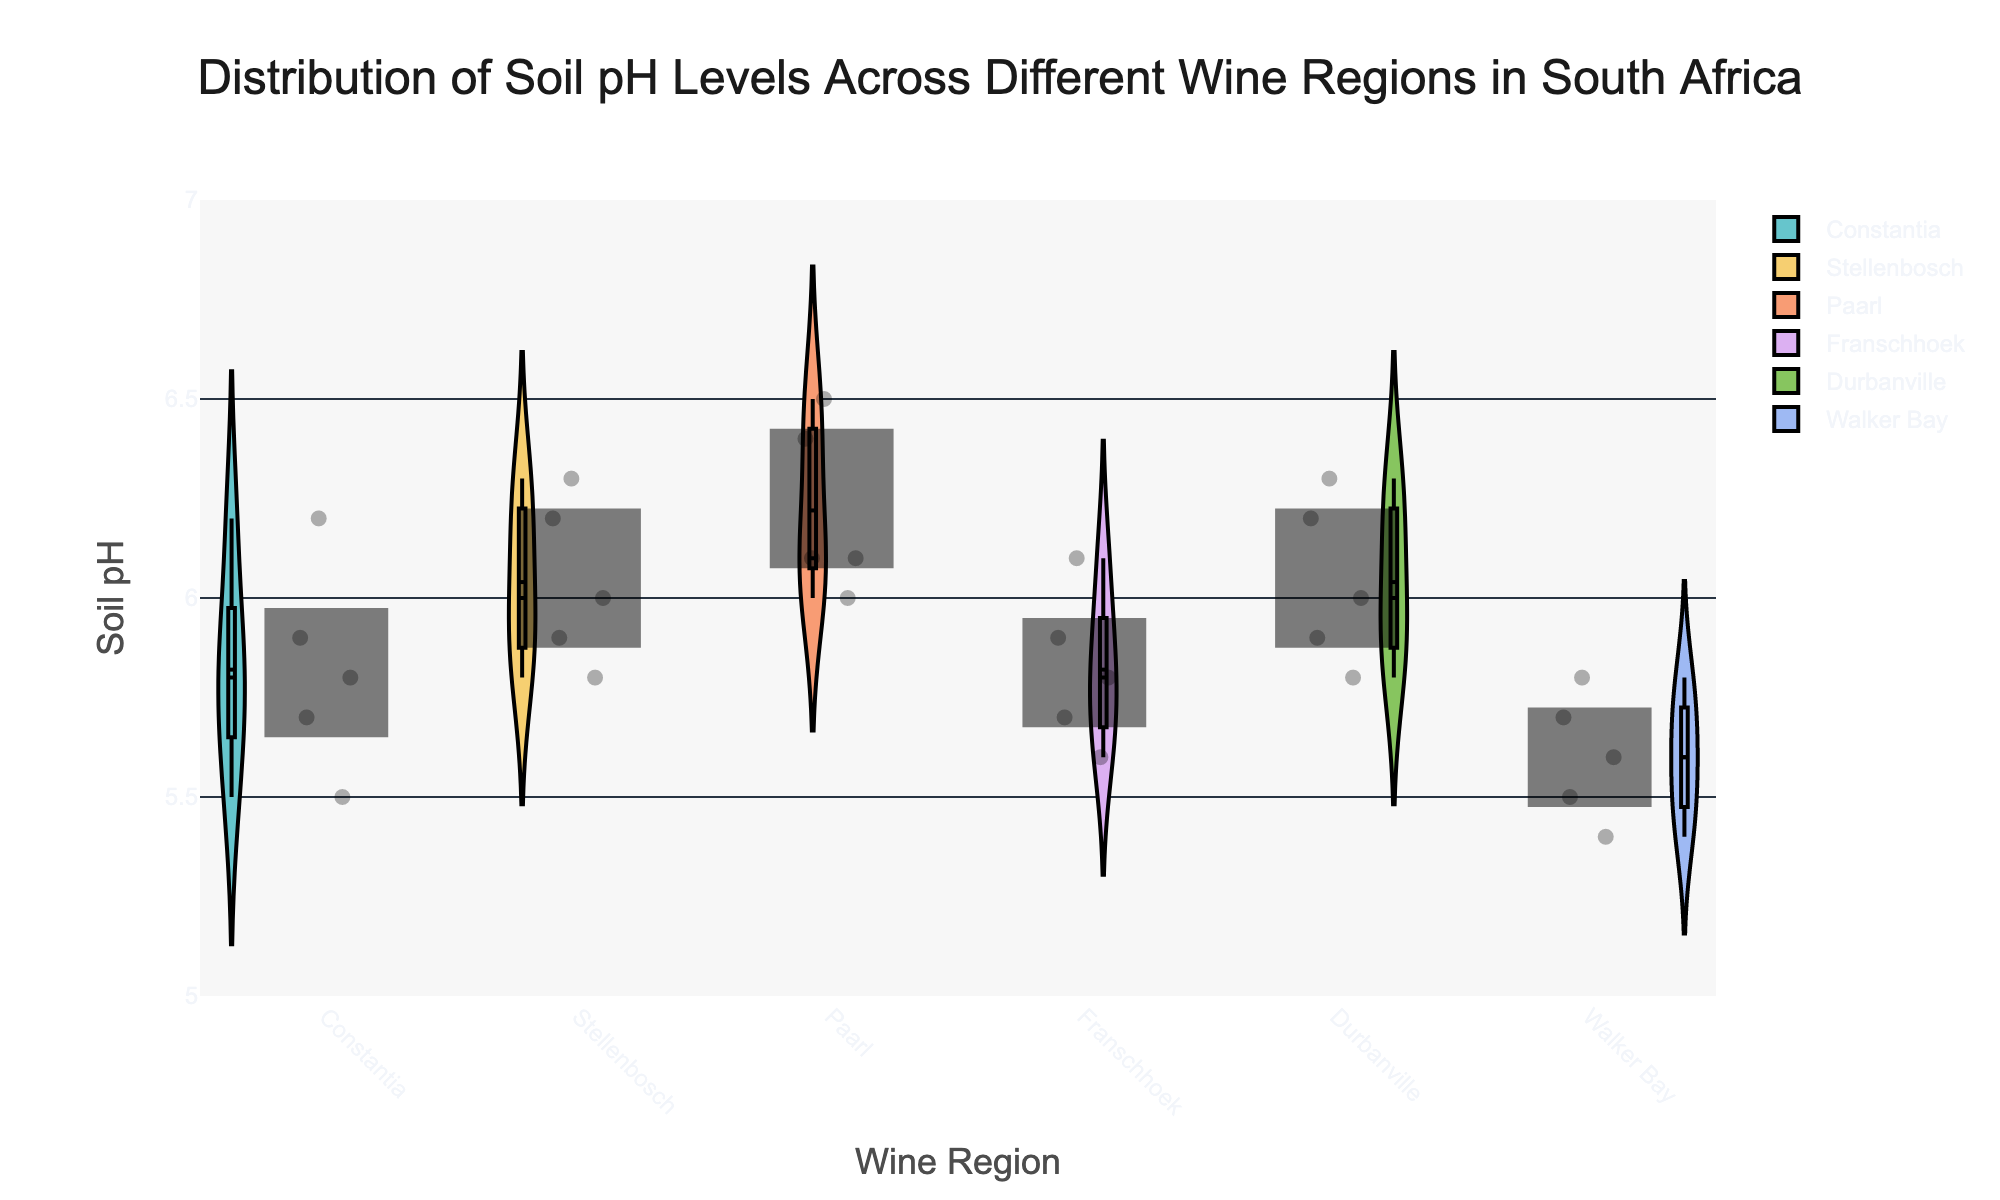What is the title of the chart? The title is located at the top of the chart and it states "Distribution of Soil pH Levels Across Different Wine Regions in South Africa".
Answer: Distribution of Soil pH Levels Across Different Wine Regions in South Africa Which wine region shows the highest median soil pH level? Look at the violin plots and identify the median line (marked by a horizontal line inside the box) for each wine region. The region with the highest median line is "Paarl".
Answer: Paarl How many data points are there for the Constantia wine region? The individual jittered points represent the data points. Count the number of points within the Constantia region section. There are 5 points.
Answer: 5 What is the range of the y-axis on this chart? The range of the y-axis can be identified by looking at the minimum and maximum values marked on the y-axis. It ranges from 5 to 7.
Answer: 5 to 7 Which wine region has the most variability in soil pH levels? Variability is shown by the width of the violin plot. The region with the widest violin plot, indicating the highest variability, is "Walker Bay".
Answer: Walker Bay What is the lowest soil pH level recorded in Walker Bay? To find the lowest soil pH level, look at the bottommost jittered point in the Walker Bay section of the chart. The lowest value is 5.4.
Answer: 5.4 Compare the mean soil pH levels between Franschhoek and Durbanville. Which region has a higher mean? Identify the mean lines for 'Franschhoek' and 'Durbanville' within their respective violin plots (usually indicated by an internal horizontal line). Durbanville has a higher mean than Franschhoek.
Answer: Durbanville Which wine region has the smallest interquartile range (IQR) for soil pH levels? The IQR is represented by the height of the box in each violin plot. The region with the smallest box is "Franschhoek".
Answer: Franschhoek What are the lowest and highest soil pH levels recorded across all regions? Look at the bottommost point and the topmost point across all the violin plots in the chart. The lowest pH level is 5.4 in Walker Bay. The highest pH level is 6.5 in Paarl.
Answer: 5.4 and 6.5 Between Stellenbosch and Constantia, which region displays a narrower spread of soil pH values? Compare the width of the violin plots for Stellenbosch and Constantia. Constantia shows a narrower spread.
Answer: Constantia 